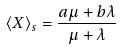<formula> <loc_0><loc_0><loc_500><loc_500>\langle X \rangle _ { s } = \frac { a \mu + b \lambda } { \mu + \lambda }</formula> 